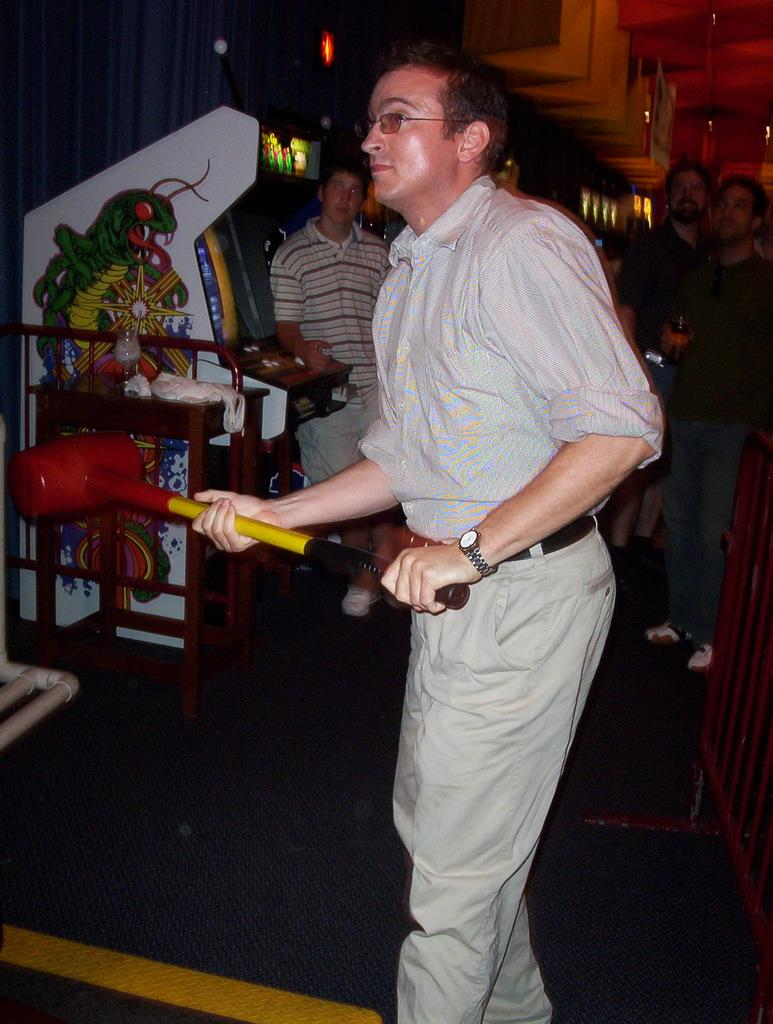How many individuals are present in the image? There are four people in the image. What is the position of the people in the image? The people are standing on the floor. What type of jellyfish can be seen in the image? There are no jellyfish present in the image; it features four people standing on the floor. What color is the sweater worn by the person in the image? There is no information about clothing or colors in the image, as it only mentions the presence of four people standing on the floor. 